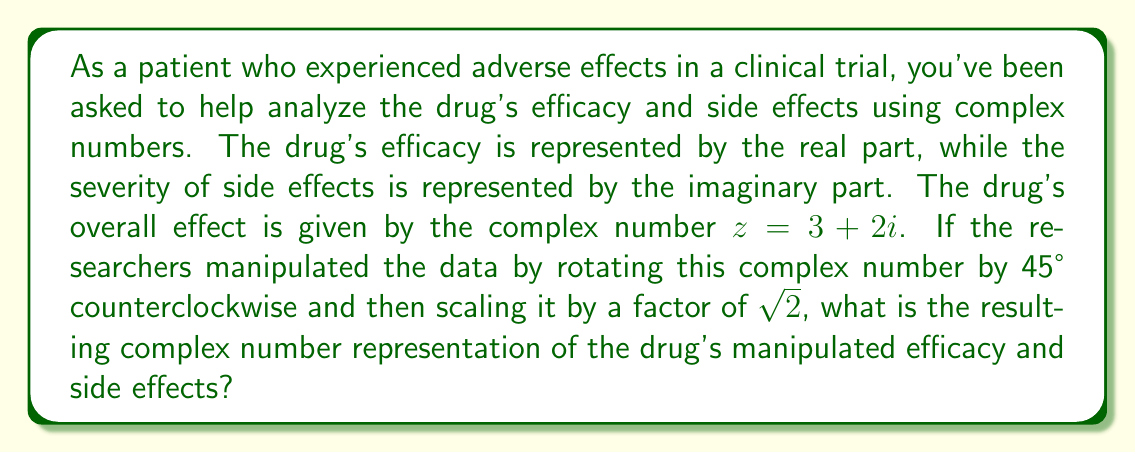Show me your answer to this math problem. To solve this problem, we'll follow these steps:

1) First, let's recall the formula for rotating a complex number by an angle $\theta$ and scaling it by a factor $r$:
   $$ w = r(z \cos\theta + iz \sin\theta) $$

2) In our case, $r = \sqrt{2}$, $\theta = 45° = \frac{\pi}{4}$ radians, and $z = 3 + 2i$

3) We know that $\cos(45°) = \sin(45°) = \frac{\sqrt{2}}{2}$

4) Let's substitute these values into our rotation formula:
   $$ w = \sqrt{2}((3+2i)(\frac{\sqrt{2}}{2}) + i(3+2i)(\frac{\sqrt{2}}{2})) $$

5) Simplify the parentheses:
   $$ w = \sqrt{2}((3\frac{\sqrt{2}}{2}+2i\frac{\sqrt{2}}{2}) + i(3\frac{\sqrt{2}}{2}+2i\frac{\sqrt{2}}{2})) $$

6) Distribute $i$ in the second term:
   $$ w = \sqrt{2}((3\frac{\sqrt{2}}{2}+2i\frac{\sqrt{2}}{2}) + (3i\frac{\sqrt{2}}{2}-2\frac{\sqrt{2}}{2})) $$

7) Combine like terms:
   $$ w = \sqrt{2}((3\frac{\sqrt{2}}{2}-2\frac{\sqrt{2}}{2}) + (2\frac{\sqrt{2}}{2}+3\frac{\sqrt{2}}{2})i) $$

8) Simplify:
   $$ w = \sqrt{2}(\frac{\sqrt{2}}{2} + 5\frac{\sqrt{2}}{2}i) $$

9) Multiply by $\sqrt{2}$:
   $$ w = 1 + 5i $$

This final complex number represents the manipulated efficacy (real part) and side effects (imaginary part) of the drug.
Answer: $w = 1 + 5i$ 